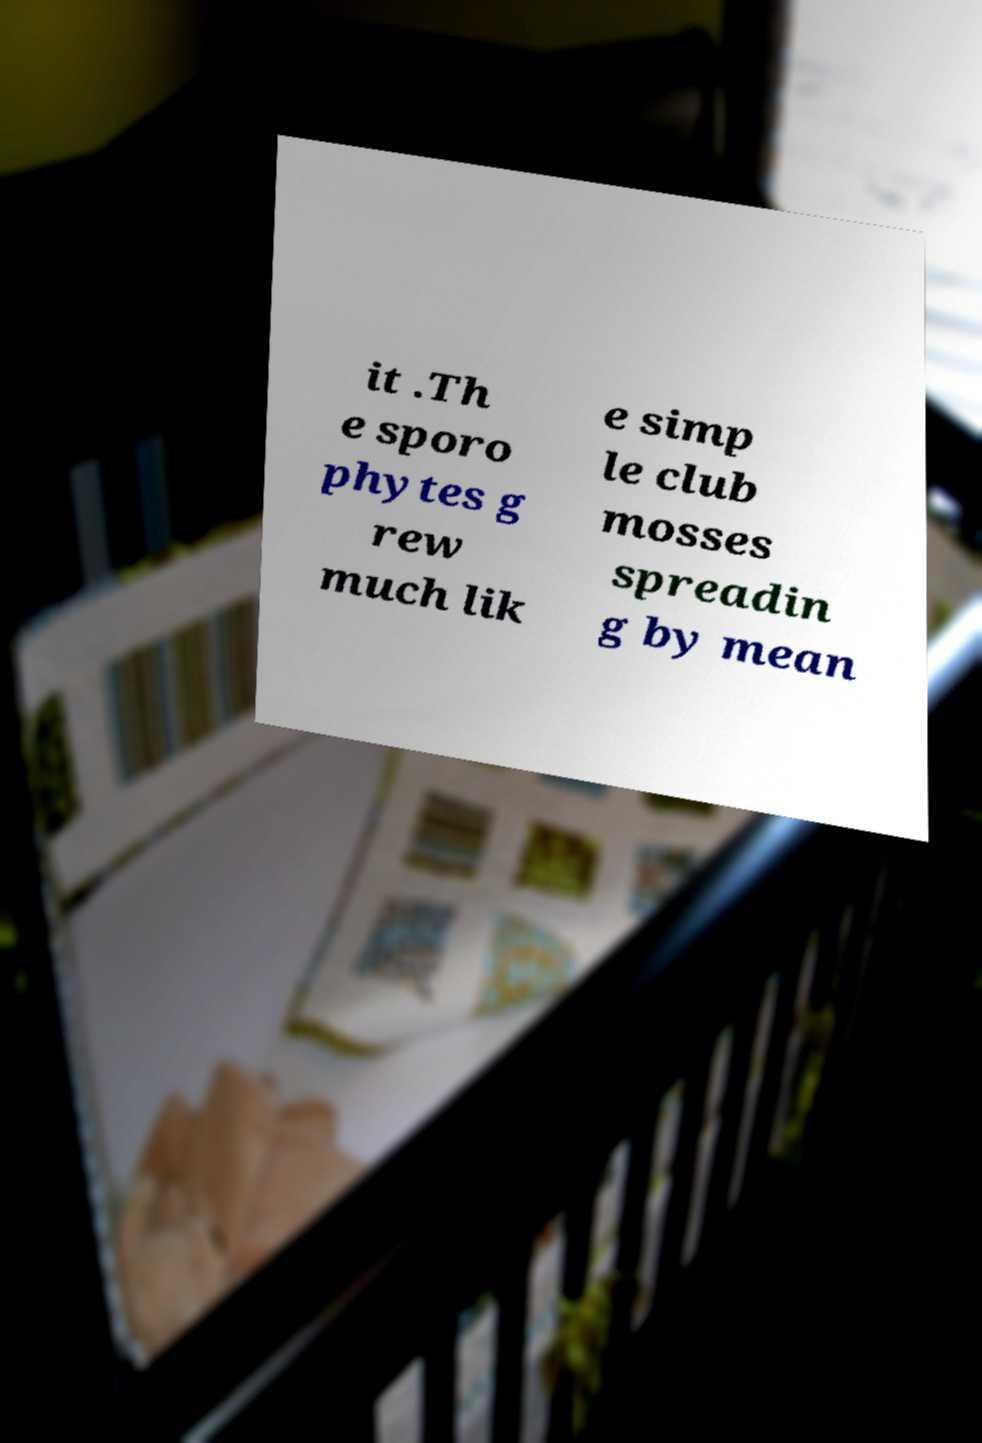There's text embedded in this image that I need extracted. Can you transcribe it verbatim? it .Th e sporo phytes g rew much lik e simp le club mosses spreadin g by mean 